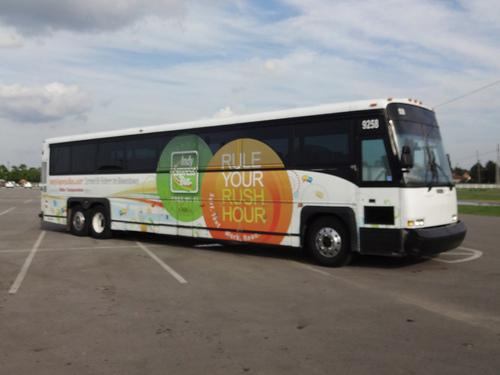Provide a brief description of the most prominent object in the image. A white and black bus is parked in a parking lot, taking up multiple spaces. Comment on the condition of the parking lot in the image. The parking lot is paved and has white lines, with some other cars parked in the distance. Please state what is written inside the orange circle on the bus. The text inside the orange circle says "Rule your rush hour." Describe the windows and other details on the front of the bus. The bus has a large front windshield for the driver, two headlights, black windshield wipers, and a black bumper. Mention the color, type, and location of the vehicle in the image. There is a white and black bus situated in a parking lot. What is the unique number for the vehicle in the image? The bus's identifying number is 9258 in white print. Describe the environment and surroundings in the image. parking lot with white lines and parked cars, green trees, and a field of grass nearby. Write about the weather and background visible in the image. Puffy white clouds and a thick grey cloud can be seen in the blue sky. Describe the circles seen on the side of the bus. There are round orange and yellow and green circles on the right side of the bus. In your own words, give a brief description of the whole image scene. A sizable white and black bus is parked in a spacious parking lot with trees, grass, and a blue sky visible in the background. 